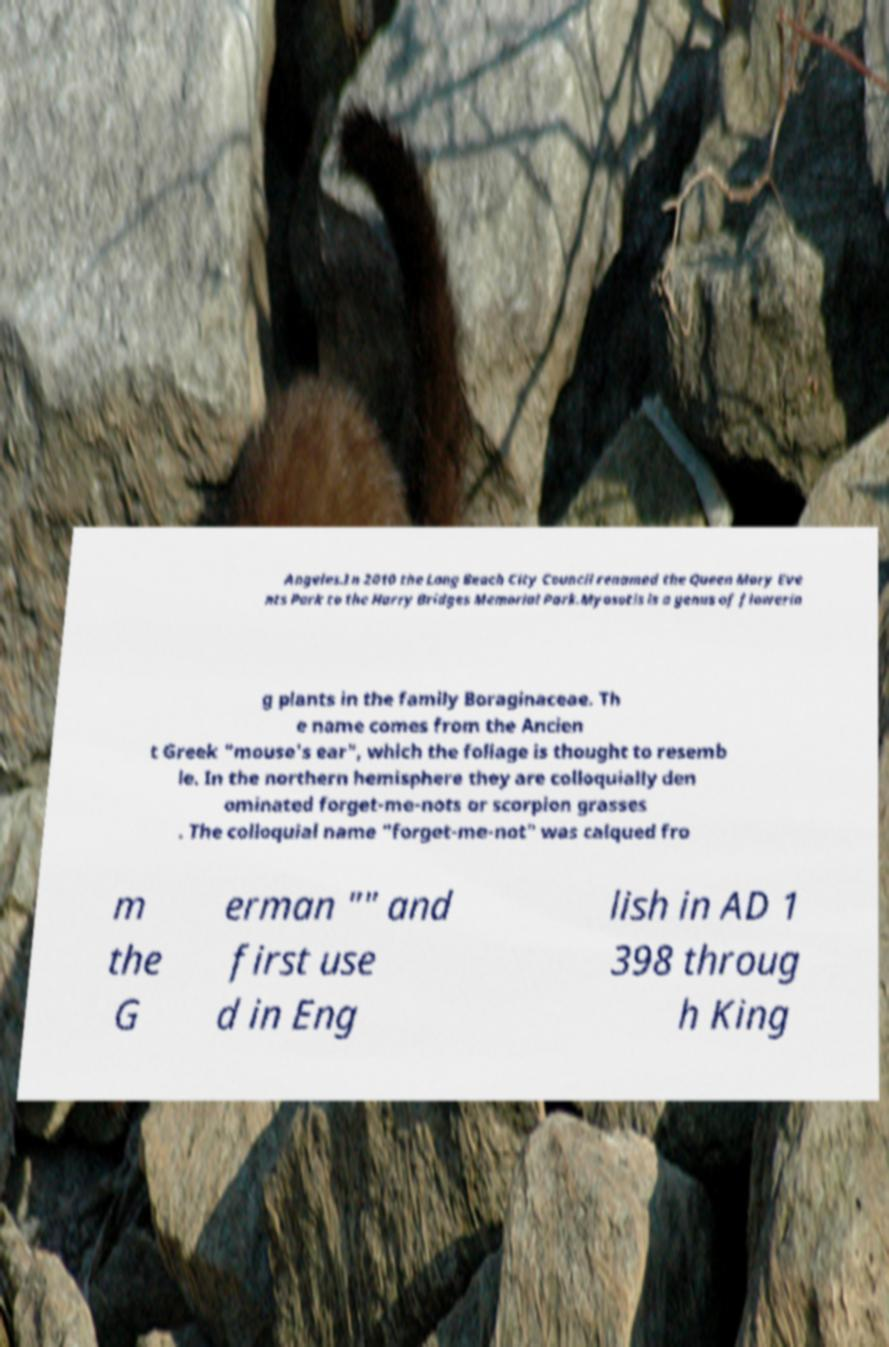There's text embedded in this image that I need extracted. Can you transcribe it verbatim? Angeles.In 2010 the Long Beach City Council renamed the Queen Mary Eve nts Park to the Harry Bridges Memorial Park.Myosotis is a genus of flowerin g plants in the family Boraginaceae. Th e name comes from the Ancien t Greek "mouse's ear", which the foliage is thought to resemb le. In the northern hemisphere they are colloquially den ominated forget-me-nots or scorpion grasses . The colloquial name "forget-me-not" was calqued fro m the G erman "" and first use d in Eng lish in AD 1 398 throug h King 